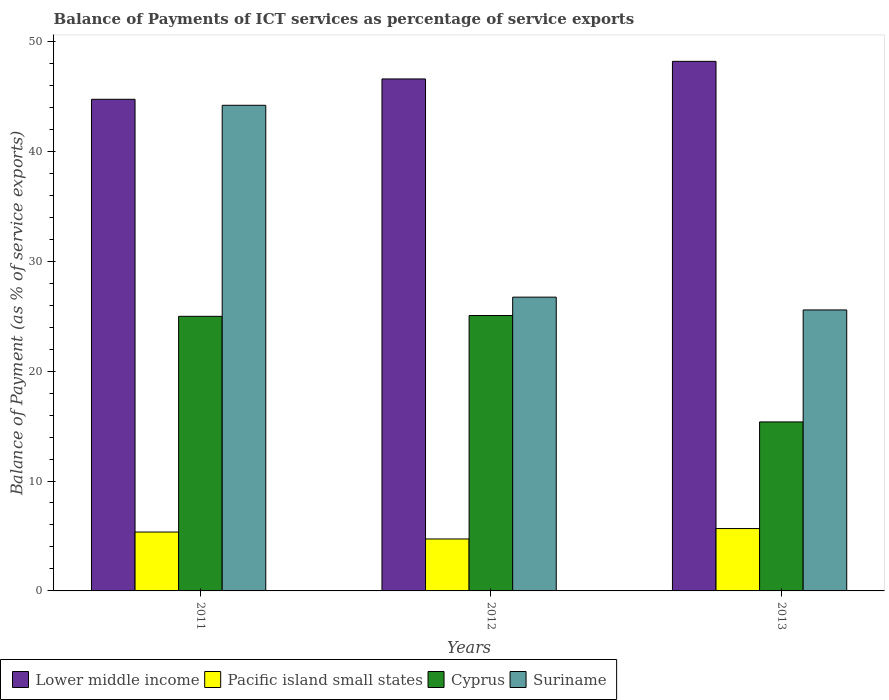Are the number of bars per tick equal to the number of legend labels?
Keep it short and to the point. Yes. Are the number of bars on each tick of the X-axis equal?
Your response must be concise. Yes. What is the label of the 2nd group of bars from the left?
Provide a short and direct response. 2012. In how many cases, is the number of bars for a given year not equal to the number of legend labels?
Offer a terse response. 0. What is the balance of payments of ICT services in Cyprus in 2013?
Offer a very short reply. 15.38. Across all years, what is the maximum balance of payments of ICT services in Suriname?
Give a very brief answer. 44.19. Across all years, what is the minimum balance of payments of ICT services in Suriname?
Provide a short and direct response. 25.56. In which year was the balance of payments of ICT services in Lower middle income maximum?
Offer a terse response. 2013. In which year was the balance of payments of ICT services in Pacific island small states minimum?
Keep it short and to the point. 2012. What is the total balance of payments of ICT services in Lower middle income in the graph?
Make the answer very short. 139.5. What is the difference between the balance of payments of ICT services in Pacific island small states in 2011 and that in 2012?
Provide a short and direct response. 0.63. What is the difference between the balance of payments of ICT services in Suriname in 2011 and the balance of payments of ICT services in Pacific island small states in 2013?
Make the answer very short. 38.51. What is the average balance of payments of ICT services in Cyprus per year?
Provide a short and direct response. 21.81. In the year 2013, what is the difference between the balance of payments of ICT services in Suriname and balance of payments of ICT services in Cyprus?
Give a very brief answer. 10.19. In how many years, is the balance of payments of ICT services in Suriname greater than 12 %?
Your answer should be very brief. 3. What is the ratio of the balance of payments of ICT services in Suriname in 2011 to that in 2013?
Offer a terse response. 1.73. What is the difference between the highest and the second highest balance of payments of ICT services in Cyprus?
Ensure brevity in your answer.  0.07. What is the difference between the highest and the lowest balance of payments of ICT services in Lower middle income?
Your answer should be compact. 3.45. In how many years, is the balance of payments of ICT services in Cyprus greater than the average balance of payments of ICT services in Cyprus taken over all years?
Give a very brief answer. 2. What does the 1st bar from the left in 2013 represents?
Your response must be concise. Lower middle income. What does the 1st bar from the right in 2013 represents?
Provide a short and direct response. Suriname. Are all the bars in the graph horizontal?
Offer a terse response. No. What is the difference between two consecutive major ticks on the Y-axis?
Your answer should be very brief. 10. Are the values on the major ticks of Y-axis written in scientific E-notation?
Ensure brevity in your answer.  No. Does the graph contain grids?
Offer a terse response. No. Where does the legend appear in the graph?
Your answer should be very brief. Bottom left. What is the title of the graph?
Keep it short and to the point. Balance of Payments of ICT services as percentage of service exports. Does "Switzerland" appear as one of the legend labels in the graph?
Your response must be concise. No. What is the label or title of the Y-axis?
Your response must be concise. Balance of Payment (as % of service exports). What is the Balance of Payment (as % of service exports) in Lower middle income in 2011?
Your answer should be compact. 44.73. What is the Balance of Payment (as % of service exports) of Pacific island small states in 2011?
Provide a succinct answer. 5.36. What is the Balance of Payment (as % of service exports) in Cyprus in 2011?
Your response must be concise. 24.98. What is the Balance of Payment (as % of service exports) of Suriname in 2011?
Provide a succinct answer. 44.19. What is the Balance of Payment (as % of service exports) in Lower middle income in 2012?
Provide a succinct answer. 46.58. What is the Balance of Payment (as % of service exports) in Pacific island small states in 2012?
Your response must be concise. 4.73. What is the Balance of Payment (as % of service exports) in Cyprus in 2012?
Keep it short and to the point. 25.06. What is the Balance of Payment (as % of service exports) of Suriname in 2012?
Provide a succinct answer. 26.73. What is the Balance of Payment (as % of service exports) of Lower middle income in 2013?
Ensure brevity in your answer.  48.18. What is the Balance of Payment (as % of service exports) in Pacific island small states in 2013?
Provide a succinct answer. 5.67. What is the Balance of Payment (as % of service exports) of Cyprus in 2013?
Provide a succinct answer. 15.38. What is the Balance of Payment (as % of service exports) of Suriname in 2013?
Your answer should be very brief. 25.56. Across all years, what is the maximum Balance of Payment (as % of service exports) in Lower middle income?
Your answer should be very brief. 48.18. Across all years, what is the maximum Balance of Payment (as % of service exports) of Pacific island small states?
Provide a short and direct response. 5.67. Across all years, what is the maximum Balance of Payment (as % of service exports) in Cyprus?
Offer a terse response. 25.06. Across all years, what is the maximum Balance of Payment (as % of service exports) of Suriname?
Offer a very short reply. 44.19. Across all years, what is the minimum Balance of Payment (as % of service exports) of Lower middle income?
Make the answer very short. 44.73. Across all years, what is the minimum Balance of Payment (as % of service exports) of Pacific island small states?
Make the answer very short. 4.73. Across all years, what is the minimum Balance of Payment (as % of service exports) of Cyprus?
Give a very brief answer. 15.38. Across all years, what is the minimum Balance of Payment (as % of service exports) of Suriname?
Your answer should be compact. 25.56. What is the total Balance of Payment (as % of service exports) in Lower middle income in the graph?
Your response must be concise. 139.5. What is the total Balance of Payment (as % of service exports) of Pacific island small states in the graph?
Your answer should be compact. 15.76. What is the total Balance of Payment (as % of service exports) in Cyprus in the graph?
Your answer should be very brief. 65.42. What is the total Balance of Payment (as % of service exports) of Suriname in the graph?
Ensure brevity in your answer.  96.48. What is the difference between the Balance of Payment (as % of service exports) of Lower middle income in 2011 and that in 2012?
Provide a succinct answer. -1.85. What is the difference between the Balance of Payment (as % of service exports) of Pacific island small states in 2011 and that in 2012?
Provide a succinct answer. 0.63. What is the difference between the Balance of Payment (as % of service exports) in Cyprus in 2011 and that in 2012?
Offer a terse response. -0.07. What is the difference between the Balance of Payment (as % of service exports) of Suriname in 2011 and that in 2012?
Your answer should be very brief. 17.46. What is the difference between the Balance of Payment (as % of service exports) of Lower middle income in 2011 and that in 2013?
Provide a short and direct response. -3.45. What is the difference between the Balance of Payment (as % of service exports) in Pacific island small states in 2011 and that in 2013?
Your answer should be very brief. -0.32. What is the difference between the Balance of Payment (as % of service exports) in Cyprus in 2011 and that in 2013?
Provide a short and direct response. 9.61. What is the difference between the Balance of Payment (as % of service exports) of Suriname in 2011 and that in 2013?
Offer a terse response. 18.62. What is the difference between the Balance of Payment (as % of service exports) of Lower middle income in 2012 and that in 2013?
Give a very brief answer. -1.6. What is the difference between the Balance of Payment (as % of service exports) in Pacific island small states in 2012 and that in 2013?
Provide a succinct answer. -0.95. What is the difference between the Balance of Payment (as % of service exports) of Cyprus in 2012 and that in 2013?
Provide a short and direct response. 9.68. What is the difference between the Balance of Payment (as % of service exports) in Suriname in 2012 and that in 2013?
Provide a short and direct response. 1.16. What is the difference between the Balance of Payment (as % of service exports) of Lower middle income in 2011 and the Balance of Payment (as % of service exports) of Pacific island small states in 2012?
Provide a short and direct response. 40. What is the difference between the Balance of Payment (as % of service exports) in Lower middle income in 2011 and the Balance of Payment (as % of service exports) in Cyprus in 2012?
Your answer should be very brief. 19.67. What is the difference between the Balance of Payment (as % of service exports) in Lower middle income in 2011 and the Balance of Payment (as % of service exports) in Suriname in 2012?
Give a very brief answer. 18. What is the difference between the Balance of Payment (as % of service exports) in Pacific island small states in 2011 and the Balance of Payment (as % of service exports) in Cyprus in 2012?
Offer a terse response. -19.7. What is the difference between the Balance of Payment (as % of service exports) in Pacific island small states in 2011 and the Balance of Payment (as % of service exports) in Suriname in 2012?
Provide a succinct answer. -21.37. What is the difference between the Balance of Payment (as % of service exports) of Cyprus in 2011 and the Balance of Payment (as % of service exports) of Suriname in 2012?
Ensure brevity in your answer.  -1.74. What is the difference between the Balance of Payment (as % of service exports) in Lower middle income in 2011 and the Balance of Payment (as % of service exports) in Pacific island small states in 2013?
Offer a terse response. 39.06. What is the difference between the Balance of Payment (as % of service exports) in Lower middle income in 2011 and the Balance of Payment (as % of service exports) in Cyprus in 2013?
Your answer should be very brief. 29.35. What is the difference between the Balance of Payment (as % of service exports) of Lower middle income in 2011 and the Balance of Payment (as % of service exports) of Suriname in 2013?
Make the answer very short. 19.17. What is the difference between the Balance of Payment (as % of service exports) of Pacific island small states in 2011 and the Balance of Payment (as % of service exports) of Cyprus in 2013?
Your answer should be compact. -10.02. What is the difference between the Balance of Payment (as % of service exports) in Pacific island small states in 2011 and the Balance of Payment (as % of service exports) in Suriname in 2013?
Ensure brevity in your answer.  -20.21. What is the difference between the Balance of Payment (as % of service exports) in Cyprus in 2011 and the Balance of Payment (as % of service exports) in Suriname in 2013?
Offer a terse response. -0.58. What is the difference between the Balance of Payment (as % of service exports) of Lower middle income in 2012 and the Balance of Payment (as % of service exports) of Pacific island small states in 2013?
Give a very brief answer. 40.91. What is the difference between the Balance of Payment (as % of service exports) in Lower middle income in 2012 and the Balance of Payment (as % of service exports) in Cyprus in 2013?
Offer a terse response. 31.21. What is the difference between the Balance of Payment (as % of service exports) in Lower middle income in 2012 and the Balance of Payment (as % of service exports) in Suriname in 2013?
Make the answer very short. 21.02. What is the difference between the Balance of Payment (as % of service exports) of Pacific island small states in 2012 and the Balance of Payment (as % of service exports) of Cyprus in 2013?
Your response must be concise. -10.65. What is the difference between the Balance of Payment (as % of service exports) in Pacific island small states in 2012 and the Balance of Payment (as % of service exports) in Suriname in 2013?
Your answer should be very brief. -20.84. What is the difference between the Balance of Payment (as % of service exports) of Cyprus in 2012 and the Balance of Payment (as % of service exports) of Suriname in 2013?
Your answer should be very brief. -0.51. What is the average Balance of Payment (as % of service exports) of Lower middle income per year?
Ensure brevity in your answer.  46.5. What is the average Balance of Payment (as % of service exports) of Pacific island small states per year?
Provide a succinct answer. 5.25. What is the average Balance of Payment (as % of service exports) in Cyprus per year?
Your answer should be compact. 21.81. What is the average Balance of Payment (as % of service exports) of Suriname per year?
Make the answer very short. 32.16. In the year 2011, what is the difference between the Balance of Payment (as % of service exports) of Lower middle income and Balance of Payment (as % of service exports) of Pacific island small states?
Offer a very short reply. 39.37. In the year 2011, what is the difference between the Balance of Payment (as % of service exports) in Lower middle income and Balance of Payment (as % of service exports) in Cyprus?
Ensure brevity in your answer.  19.75. In the year 2011, what is the difference between the Balance of Payment (as % of service exports) of Lower middle income and Balance of Payment (as % of service exports) of Suriname?
Keep it short and to the point. 0.55. In the year 2011, what is the difference between the Balance of Payment (as % of service exports) of Pacific island small states and Balance of Payment (as % of service exports) of Cyprus?
Offer a very short reply. -19.63. In the year 2011, what is the difference between the Balance of Payment (as % of service exports) of Pacific island small states and Balance of Payment (as % of service exports) of Suriname?
Offer a very short reply. -38.83. In the year 2011, what is the difference between the Balance of Payment (as % of service exports) in Cyprus and Balance of Payment (as % of service exports) in Suriname?
Give a very brief answer. -19.2. In the year 2012, what is the difference between the Balance of Payment (as % of service exports) in Lower middle income and Balance of Payment (as % of service exports) in Pacific island small states?
Offer a very short reply. 41.86. In the year 2012, what is the difference between the Balance of Payment (as % of service exports) in Lower middle income and Balance of Payment (as % of service exports) in Cyprus?
Ensure brevity in your answer.  21.52. In the year 2012, what is the difference between the Balance of Payment (as % of service exports) in Lower middle income and Balance of Payment (as % of service exports) in Suriname?
Your answer should be compact. 19.85. In the year 2012, what is the difference between the Balance of Payment (as % of service exports) of Pacific island small states and Balance of Payment (as % of service exports) of Cyprus?
Ensure brevity in your answer.  -20.33. In the year 2012, what is the difference between the Balance of Payment (as % of service exports) of Pacific island small states and Balance of Payment (as % of service exports) of Suriname?
Your answer should be compact. -22. In the year 2012, what is the difference between the Balance of Payment (as % of service exports) in Cyprus and Balance of Payment (as % of service exports) in Suriname?
Keep it short and to the point. -1.67. In the year 2013, what is the difference between the Balance of Payment (as % of service exports) in Lower middle income and Balance of Payment (as % of service exports) in Pacific island small states?
Keep it short and to the point. 42.51. In the year 2013, what is the difference between the Balance of Payment (as % of service exports) of Lower middle income and Balance of Payment (as % of service exports) of Cyprus?
Your answer should be very brief. 32.81. In the year 2013, what is the difference between the Balance of Payment (as % of service exports) of Lower middle income and Balance of Payment (as % of service exports) of Suriname?
Offer a very short reply. 22.62. In the year 2013, what is the difference between the Balance of Payment (as % of service exports) in Pacific island small states and Balance of Payment (as % of service exports) in Cyprus?
Provide a succinct answer. -9.7. In the year 2013, what is the difference between the Balance of Payment (as % of service exports) of Pacific island small states and Balance of Payment (as % of service exports) of Suriname?
Your answer should be very brief. -19.89. In the year 2013, what is the difference between the Balance of Payment (as % of service exports) of Cyprus and Balance of Payment (as % of service exports) of Suriname?
Make the answer very short. -10.19. What is the ratio of the Balance of Payment (as % of service exports) of Lower middle income in 2011 to that in 2012?
Ensure brevity in your answer.  0.96. What is the ratio of the Balance of Payment (as % of service exports) of Pacific island small states in 2011 to that in 2012?
Offer a terse response. 1.13. What is the ratio of the Balance of Payment (as % of service exports) of Cyprus in 2011 to that in 2012?
Your response must be concise. 1. What is the ratio of the Balance of Payment (as % of service exports) in Suriname in 2011 to that in 2012?
Provide a short and direct response. 1.65. What is the ratio of the Balance of Payment (as % of service exports) of Lower middle income in 2011 to that in 2013?
Offer a terse response. 0.93. What is the ratio of the Balance of Payment (as % of service exports) in Pacific island small states in 2011 to that in 2013?
Offer a very short reply. 0.94. What is the ratio of the Balance of Payment (as % of service exports) of Cyprus in 2011 to that in 2013?
Offer a very short reply. 1.62. What is the ratio of the Balance of Payment (as % of service exports) of Suriname in 2011 to that in 2013?
Your answer should be very brief. 1.73. What is the ratio of the Balance of Payment (as % of service exports) in Lower middle income in 2012 to that in 2013?
Offer a terse response. 0.97. What is the ratio of the Balance of Payment (as % of service exports) in Pacific island small states in 2012 to that in 2013?
Make the answer very short. 0.83. What is the ratio of the Balance of Payment (as % of service exports) of Cyprus in 2012 to that in 2013?
Provide a short and direct response. 1.63. What is the ratio of the Balance of Payment (as % of service exports) of Suriname in 2012 to that in 2013?
Offer a very short reply. 1.05. What is the difference between the highest and the second highest Balance of Payment (as % of service exports) in Lower middle income?
Keep it short and to the point. 1.6. What is the difference between the highest and the second highest Balance of Payment (as % of service exports) of Pacific island small states?
Ensure brevity in your answer.  0.32. What is the difference between the highest and the second highest Balance of Payment (as % of service exports) in Cyprus?
Offer a very short reply. 0.07. What is the difference between the highest and the second highest Balance of Payment (as % of service exports) in Suriname?
Your answer should be compact. 17.46. What is the difference between the highest and the lowest Balance of Payment (as % of service exports) in Lower middle income?
Provide a short and direct response. 3.45. What is the difference between the highest and the lowest Balance of Payment (as % of service exports) in Pacific island small states?
Offer a terse response. 0.95. What is the difference between the highest and the lowest Balance of Payment (as % of service exports) of Cyprus?
Give a very brief answer. 9.68. What is the difference between the highest and the lowest Balance of Payment (as % of service exports) of Suriname?
Offer a terse response. 18.62. 